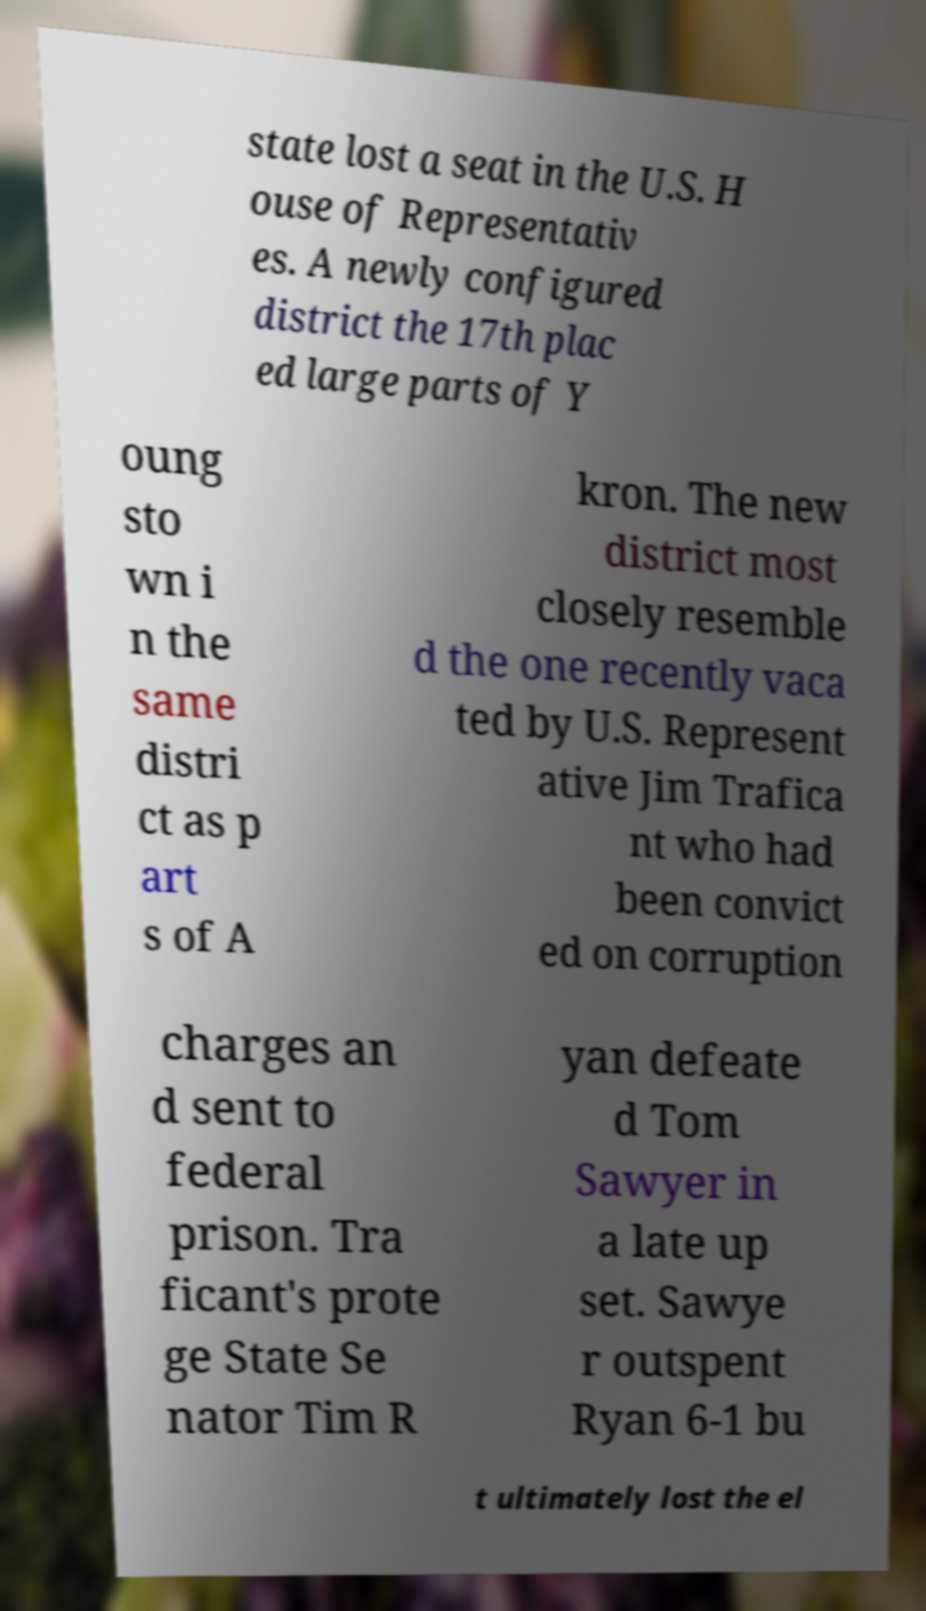Can you read and provide the text displayed in the image?This photo seems to have some interesting text. Can you extract and type it out for me? state lost a seat in the U.S. H ouse of Representativ es. A newly configured district the 17th plac ed large parts of Y oung sto wn i n the same distri ct as p art s of A kron. The new district most closely resemble d the one recently vaca ted by U.S. Represent ative Jim Trafica nt who had been convict ed on corruption charges an d sent to federal prison. Tra ficant's prote ge State Se nator Tim R yan defeate d Tom Sawyer in a late up set. Sawye r outspent Ryan 6-1 bu t ultimately lost the el 